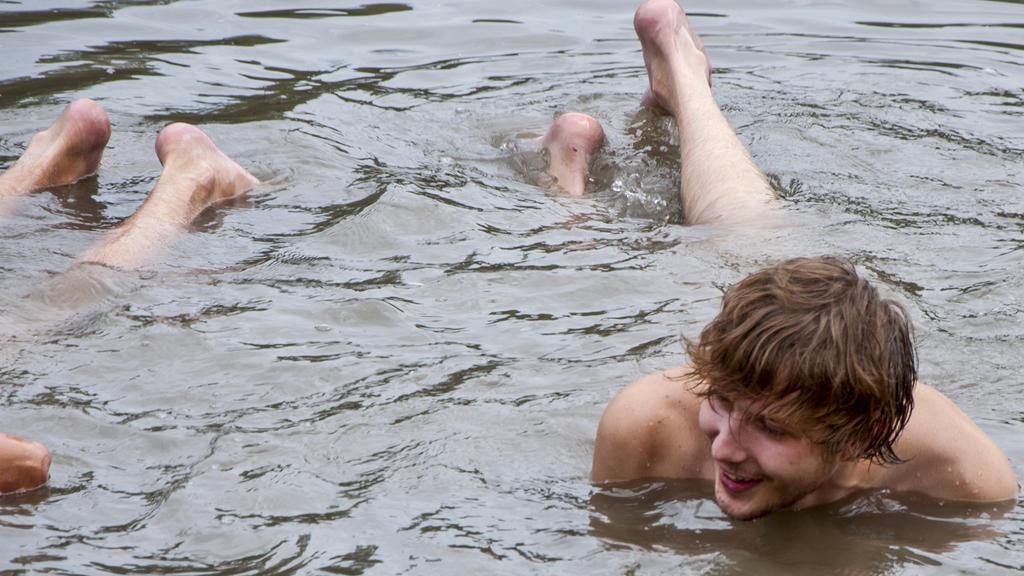How many people are in the water in the image? There are two persons in the water in the image. Can you describe the expression of one of the persons? One of the persons, presumably a man, is smiling. What type of secretary can be seen in the cemetery in the image? There is no secretary or cemetery present in the image; it features two persons in the water. 